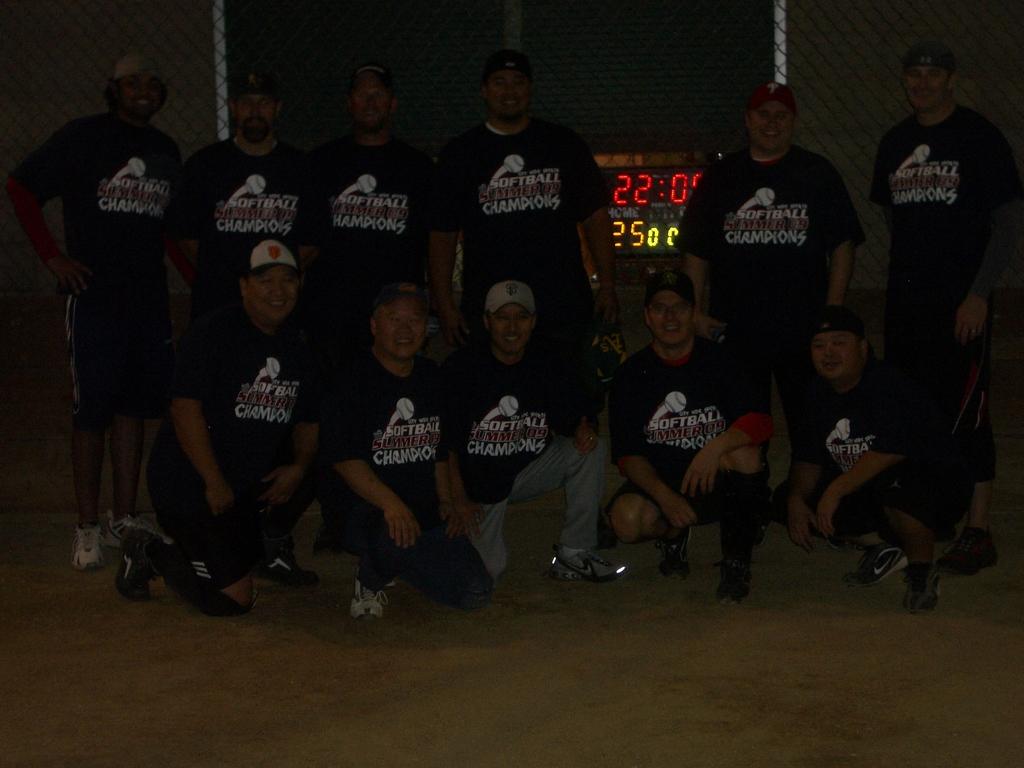What number is above the man's shoulder?
Your response must be concise. 22. What sport is this team champions of?
Keep it short and to the point. Softball. 